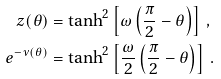Convert formula to latex. <formula><loc_0><loc_0><loc_500><loc_500>z ( \theta ) & = \tanh ^ { 2 } \left [ \omega \left ( \frac { \pi } { 2 } - \theta \right ) \right ] \, , \\ e ^ { - \nu ( \theta ) } & = \tanh ^ { 2 } \left [ \frac { \omega } { 2 } \left ( \frac { \pi } { 2 } - \theta \right ) \right ] \, .</formula> 